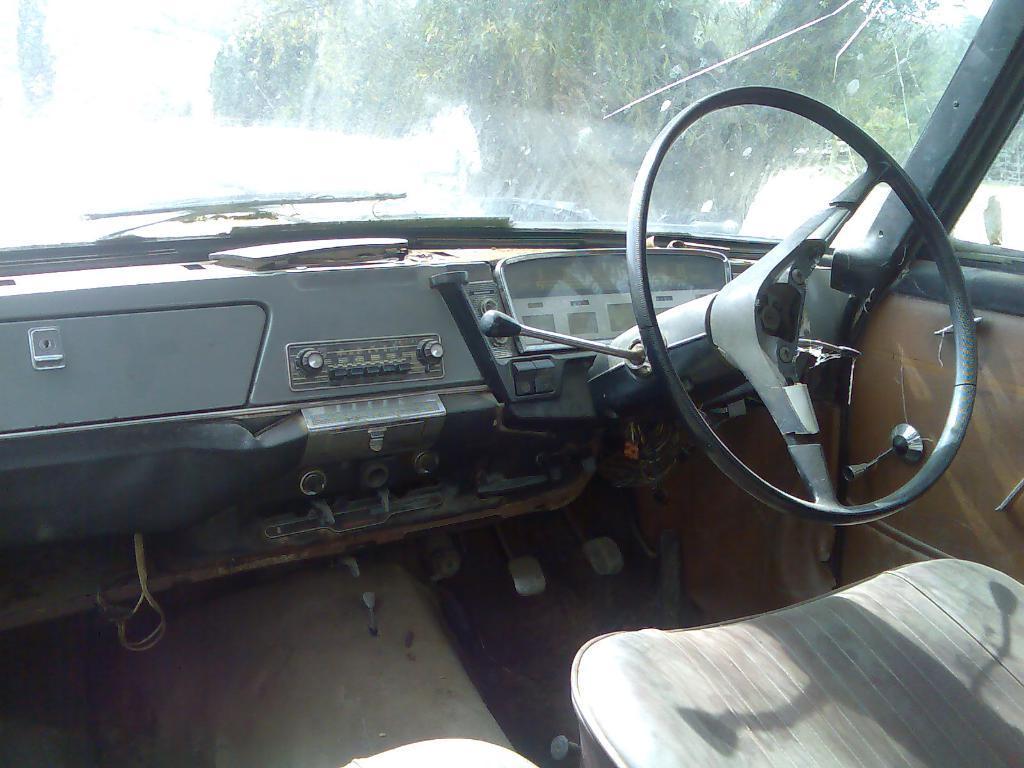In one or two sentences, can you explain what this image depicts? In this picture I can see the inside view of a vehicle, and in the background there are trees. 